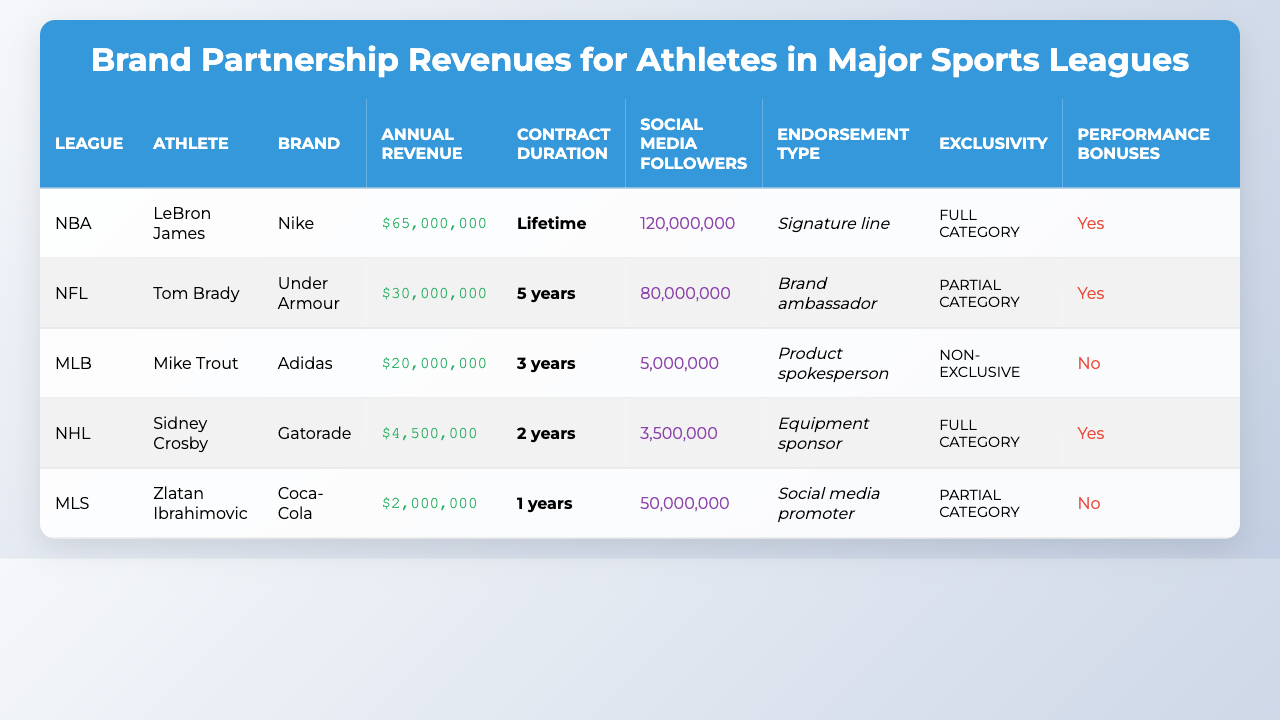What is the annual revenue of LeBron James from his brand partnerships? The table shows that LeBron James has an annual revenue of $65,000,000 from brand partnerships.
Answer: $65,000,000 Which athlete has the shortest contract duration? Based on the table, Zlatan Ibrahimovic has the shortest contract duration of 1 year.
Answer: 1 year What endorsement type is associated with Tom Brady? The table indicates that Tom Brady's endorsement type is "Brand ambassador."
Answer: Brand ambassador Are there performance bonuses included in Mike Trout's contract? The table states that Mike Trout does not have performance bonuses included in his contract.
Answer: No Who has the highest number of social media followers? The table shows that LeBron James has the highest number of social media followers at 120,000,000.
Answer: 120,000,000 What is the average annual revenue from brand partnerships for all athletes? To find the average, sum the revenues ($65,000,000 + $30,000,000 + $20,000,000 + $4,500,000 + $2,000,000 = $121,500,000) and divide by the number of athletes (5). The average is $121,500,000 / 5 = $24,300,000.
Answer: $24,300,000 Which athlete represents a brand under a "Lifetime" contract? According to the table, LeBron James has a "Lifetime" contract.
Answer: LeBron James Is there any athlete involved in charity as part of their endorsement? The table shows that both LeBron James and Sidney Crosby have charity involvement as required in their contracts.
Answer: Yes What is the total annual revenue for athletes with a "Full category" exclusivity? The total annual revenue is calculated by adding LeBron James ($65,000,000) and Sidney Crosby ($4,500,000). The total is $65,000,000 + $4,500,000 = $69,500,000.
Answer: $69,500,000 Which athlete has the highest annual revenue but does not have performance bonuses? Mike Trout has the highest annual revenue ($20,000,000) without performance bonuses in his contract.
Answer: Mike Trout 